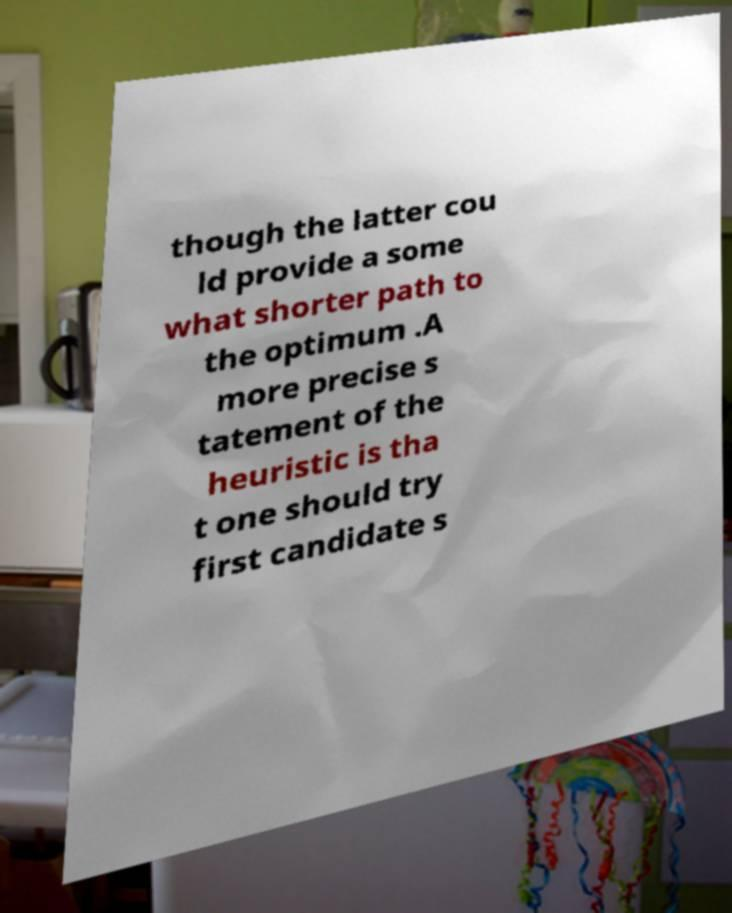There's text embedded in this image that I need extracted. Can you transcribe it verbatim? though the latter cou ld provide a some what shorter path to the optimum .A more precise s tatement of the heuristic is tha t one should try first candidate s 